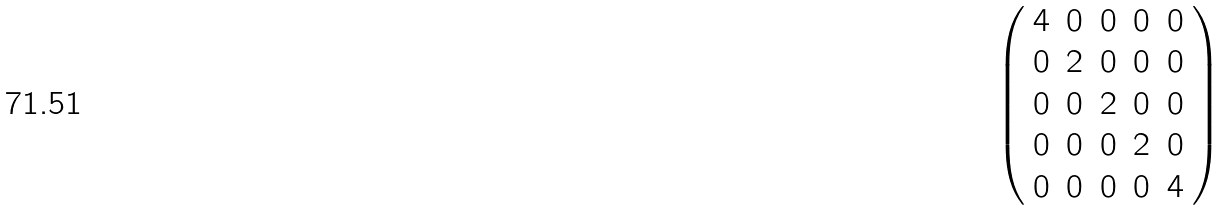<formula> <loc_0><loc_0><loc_500><loc_500>\left ( \begin{array} { c c c c c } 4 & 0 & 0 & 0 & 0 \\ 0 & 2 & 0 & 0 & 0 \\ 0 & 0 & 2 & 0 & 0 \\ 0 & 0 & 0 & 2 & 0 \\ 0 & 0 & 0 & 0 & 4 \\ \end{array} \right )</formula> 